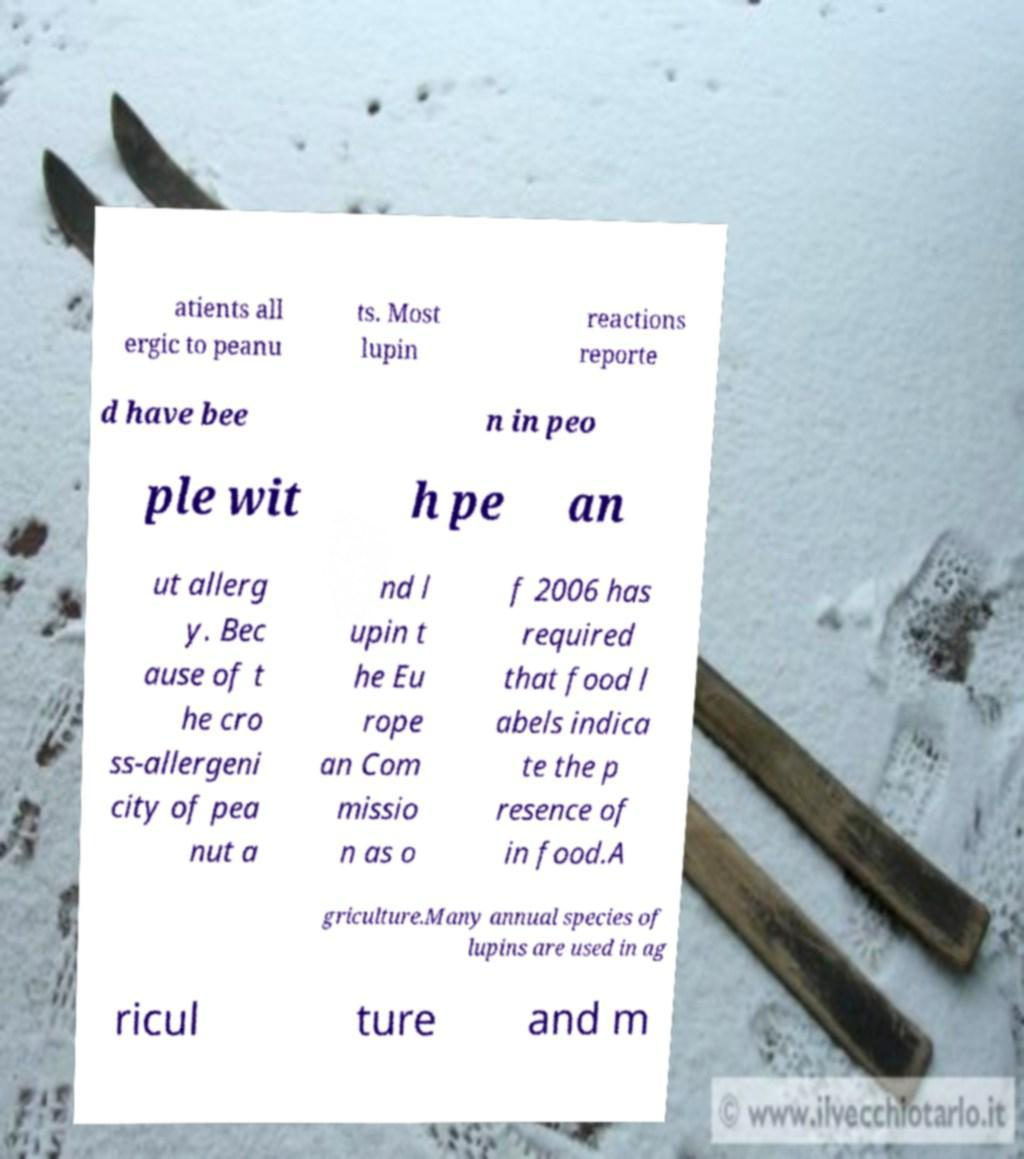Can you read and provide the text displayed in the image?This photo seems to have some interesting text. Can you extract and type it out for me? atients all ergic to peanu ts. Most lupin reactions reporte d have bee n in peo ple wit h pe an ut allerg y. Bec ause of t he cro ss-allergeni city of pea nut a nd l upin t he Eu rope an Com missio n as o f 2006 has required that food l abels indica te the p resence of in food.A griculture.Many annual species of lupins are used in ag ricul ture and m 